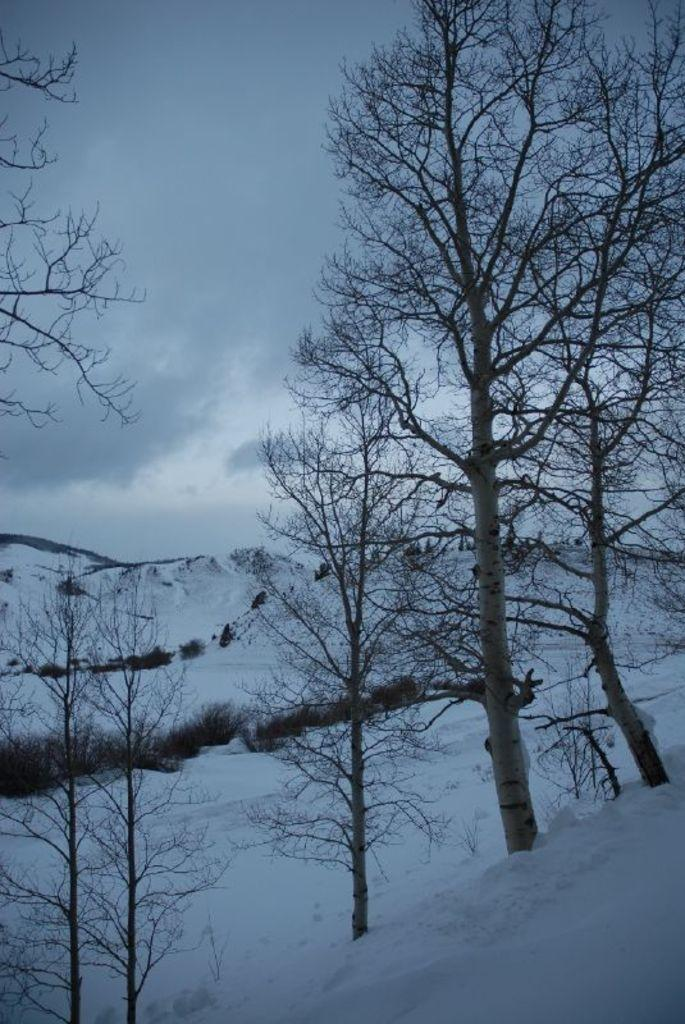What type of vegetation can be seen in the image? There are trees in the image. What is the weather like in the image? There is snow visible in the image, indicating a cold and likely snowy environment. What else can be seen in the sky besides the trees? The sky is visible in the image, but there is no other information provided about what can be seen in the sky. How many minutes does it take for the deer to cross the tray in the image? There is no deer or tray present in the image, so this question cannot be answered. 